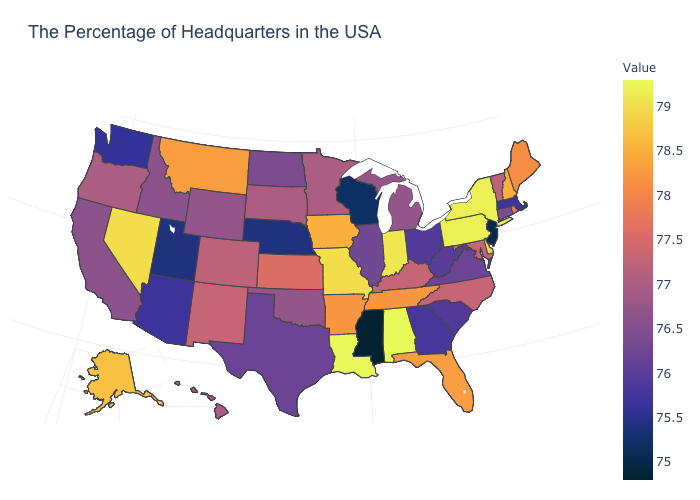Is the legend a continuous bar?
Write a very short answer. Yes. Is the legend a continuous bar?
Write a very short answer. Yes. Is the legend a continuous bar?
Answer briefly. Yes. Does Mississippi have the lowest value in the USA?
Short answer required. Yes. Which states have the lowest value in the USA?
Short answer required. Mississippi. Among the states that border Maine , which have the lowest value?
Concise answer only. New Hampshire. Does the map have missing data?
Answer briefly. No. 